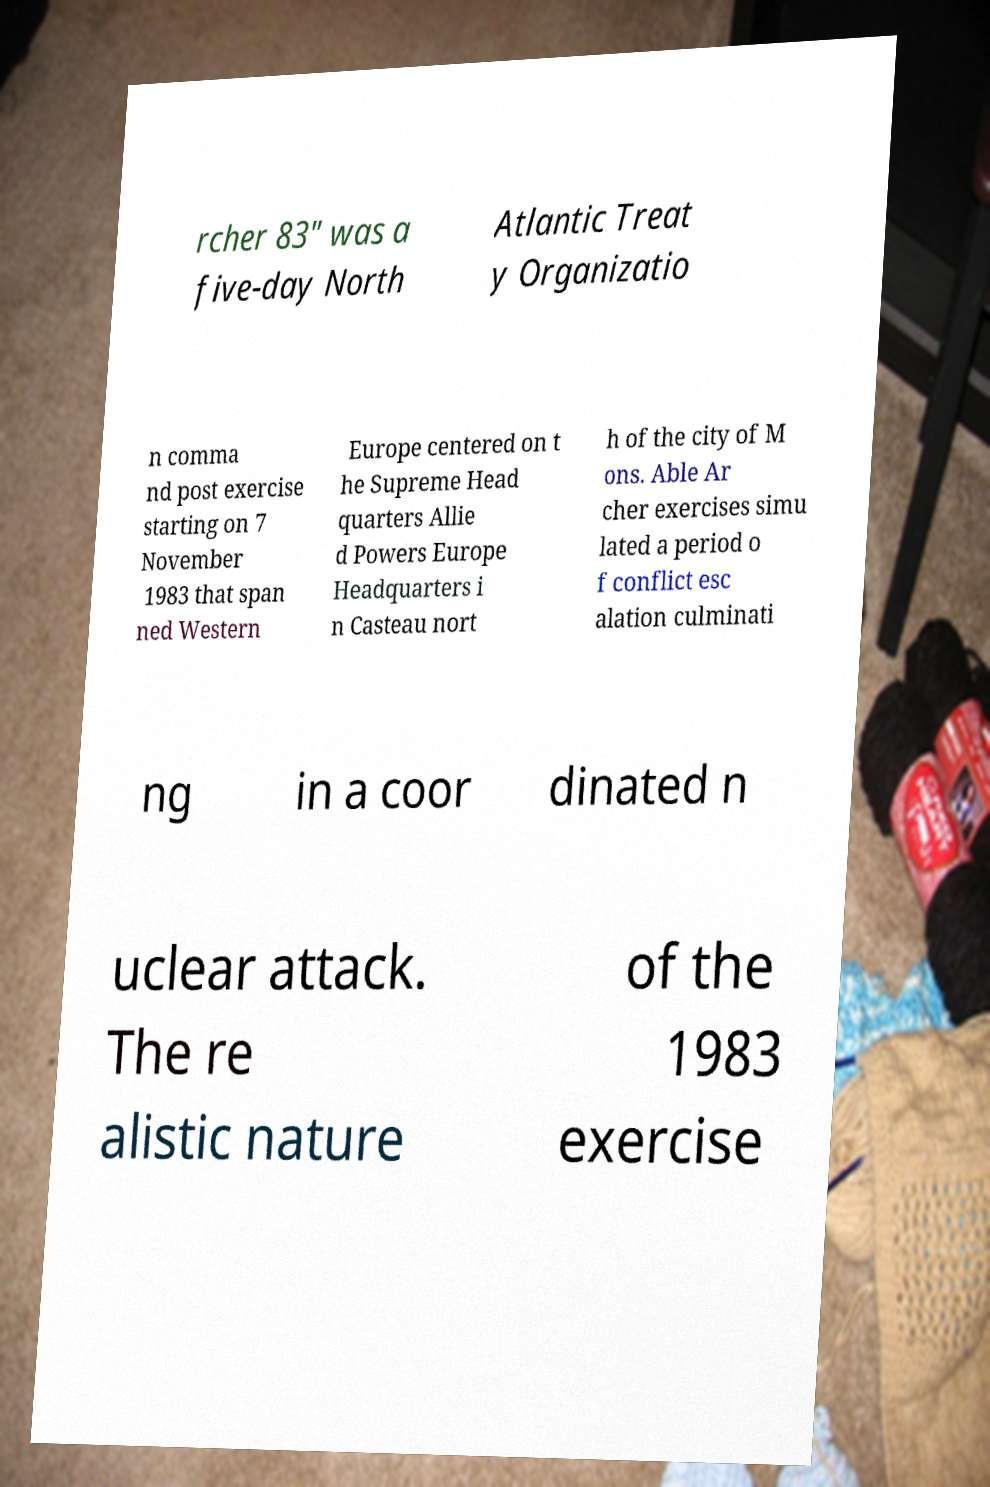Please read and relay the text visible in this image. What does it say? rcher 83" was a five-day North Atlantic Treat y Organizatio n comma nd post exercise starting on 7 November 1983 that span ned Western Europe centered on t he Supreme Head quarters Allie d Powers Europe Headquarters i n Casteau nort h of the city of M ons. Able Ar cher exercises simu lated a period o f conflict esc alation culminati ng in a coor dinated n uclear attack. The re alistic nature of the 1983 exercise 